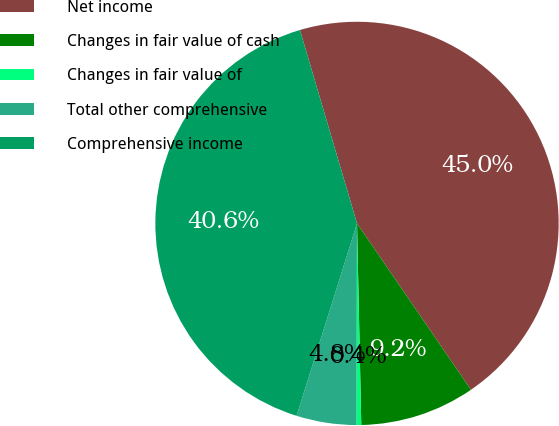Convert chart to OTSL. <chart><loc_0><loc_0><loc_500><loc_500><pie_chart><fcel>Net income<fcel>Changes in fair value of cash<fcel>Changes in fair value of<fcel>Total other comprehensive<fcel>Comprehensive income<nl><fcel>45.01%<fcel>9.22%<fcel>0.38%<fcel>4.8%<fcel>40.59%<nl></chart> 